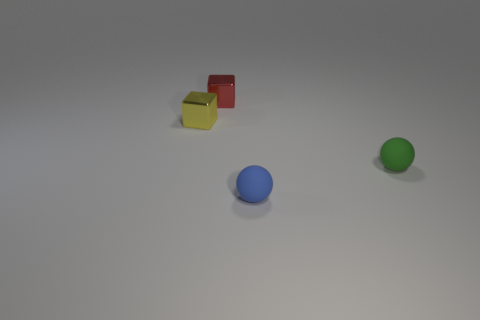Add 1 tiny gray matte cylinders. How many objects exist? 5 Subtract 0 yellow spheres. How many objects are left? 4 Subtract all blue matte spheres. Subtract all blue objects. How many objects are left? 2 Add 4 tiny yellow metallic cubes. How many tiny yellow metallic cubes are left? 5 Add 4 brown matte objects. How many brown matte objects exist? 4 